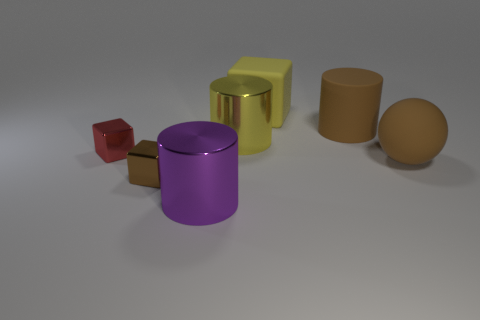What is the shape of the small brown thing that is made of the same material as the yellow cylinder?
Ensure brevity in your answer.  Cube. There is a big yellow thing to the right of the large yellow shiny cylinder; is it the same shape as the small red shiny object?
Provide a short and direct response. Yes. The big brown object behind the brown matte sphere has what shape?
Offer a very short reply. Cylinder. There is a metal thing that is the same color as the big sphere; what is its shape?
Provide a short and direct response. Cube. How many brown spheres are the same size as the matte cube?
Keep it short and to the point. 1. What is the color of the big cube?
Ensure brevity in your answer.  Yellow. Does the matte sphere have the same color as the large cylinder on the right side of the rubber cube?
Give a very brief answer. Yes. There is a brown cube that is the same material as the big purple thing; what is its size?
Provide a short and direct response. Small. Are there any other large rubber balls of the same color as the ball?
Make the answer very short. No. How many objects are brown objects that are to the right of the big purple metallic object or large objects?
Keep it short and to the point. 5. 